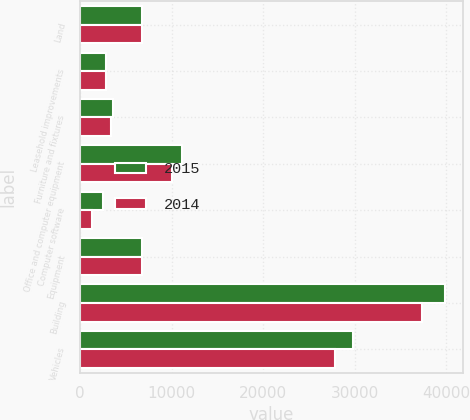<chart> <loc_0><loc_0><loc_500><loc_500><stacked_bar_chart><ecel><fcel>Land<fcel>Leasehold improvements<fcel>Furniture and fixtures<fcel>Office and computer equipment<fcel>Computer software<fcel>Equipment<fcel>Building<fcel>Vehicles<nl><fcel>2015<fcel>6792<fcel>2804<fcel>3551<fcel>11080<fcel>2530<fcel>6792<fcel>39848<fcel>29804<nl><fcel>2014<fcel>6792<fcel>2796<fcel>3371<fcel>10072<fcel>1317<fcel>6792<fcel>37311<fcel>27813<nl></chart> 